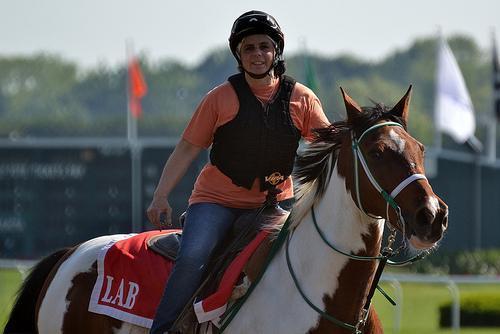How many women are there?
Give a very brief answer. 1. How many black horses are there?
Give a very brief answer. 0. 